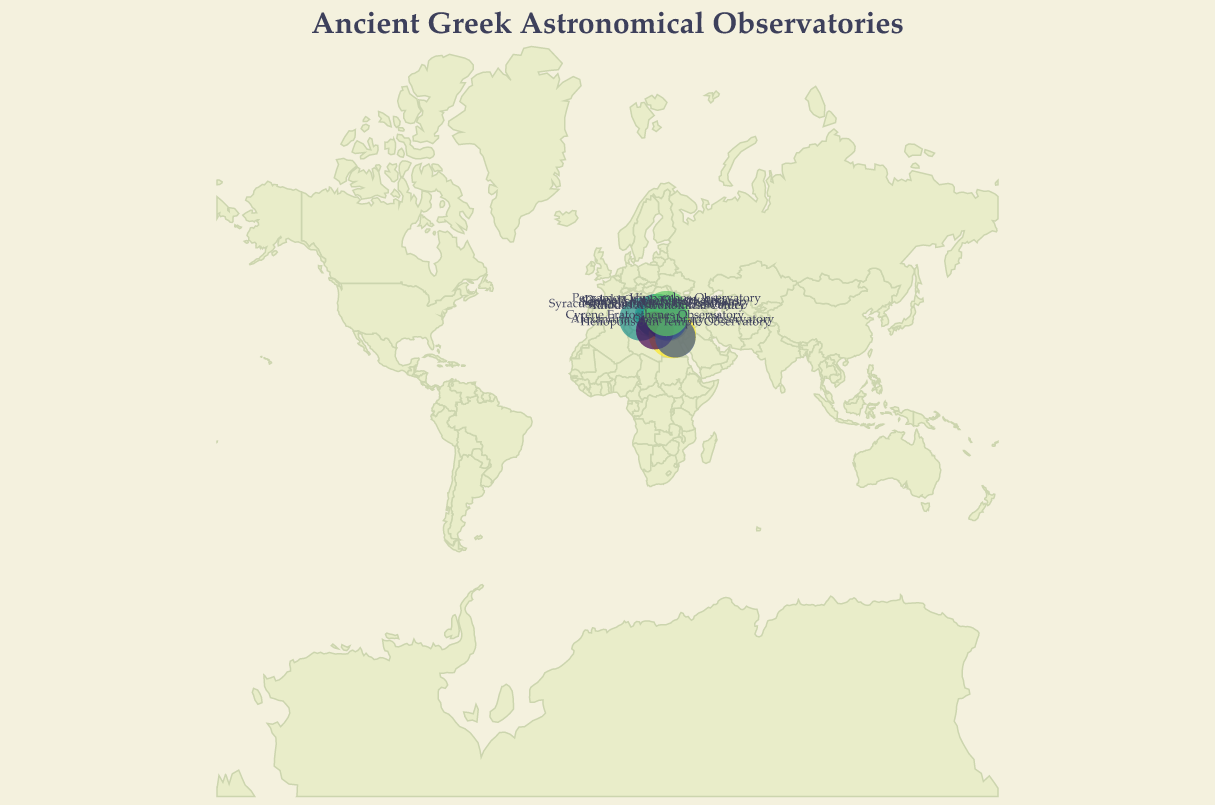What is the title of the figure? The title is written at the top of the figure. It explicitly states the subject of the visualization.
Answer: Ancient Greek Astronomical Observatories How many observatories are depicted in the figure? By counting all the points or textual entries present on the map, we can determine the number of observatories.
Answer: 10 Which observatory has the highest importance value? From the color intensity and the size of the circles marking the observatories, the one with the highest value can be identified.
Answer: Alexandria Great Library Observatory What is the range of importance values for the observatories? By examining the size legend provided at the bottom right and cross-referencing with the values listed for each observatory, we can determine the range.
Answer: 6 to 10 Which observatory is located at the highest latitude? Looking at the northernmost point labeled on the map will indicate the observatory at the highest latitude.
Answer: Pergamon Hipparchos Observatory Which two observatories are closest to each other in terms of latitude and longitude? By visually inspecting the figure and observing proximity, the two nearest points can be ascertained.
Answer: Rhodes Astronomical Center and Knidos Eudoxus Observatory Compare the importance of Delphi Oracle Observatory to that of Pergamon Hipparchos Observatory. By comparing their importance values in the dataset, the relationship between the two can be determined.
Answer: Delphi Oracle Observatory is less important by 1 point Which observatories are located within modern-day Greece? By identifying observatories with coordinates corresponding to locations in modern-day Greece, these can be listed.
Answer: Acropolis Observatory Athens, Delphi Oracle Observatory, Samos Aristarchus Observatory What is the average importance of the observatories? Summing up the importance values of all observatories and dividing by the total number of observatories gives the average importance.
Answer: 7.9 How is the importance of observatories represented in the figure? By referring to the visual elements used (such as size and color of circles), the method of representing importance can be explained.
Answer: Size and color of circles 